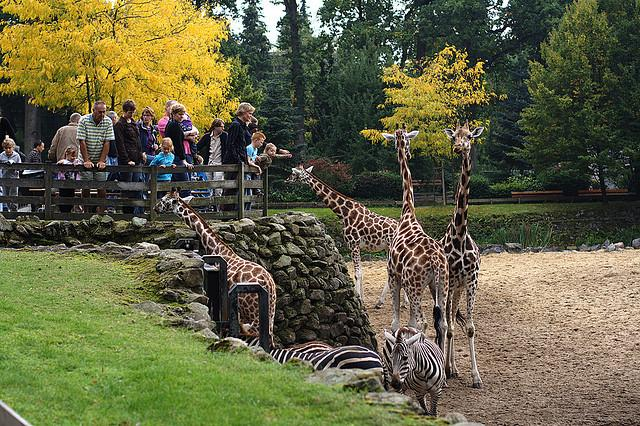How many giraffes are standing in the zoo enclosure around the people? four 